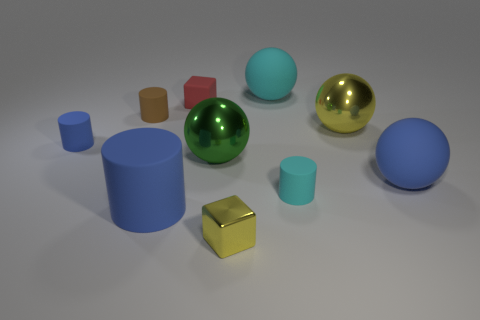Subtract all big blue rubber balls. How many balls are left? 3 Subtract all brown cylinders. How many cylinders are left? 3 Subtract all gray spheres. How many blue cylinders are left? 2 Subtract all cylinders. How many objects are left? 6 Subtract all yellow spheres. Subtract all big blue rubber balls. How many objects are left? 8 Add 5 tiny red objects. How many tiny red objects are left? 6 Add 4 green spheres. How many green spheres exist? 5 Subtract 1 cyan spheres. How many objects are left? 9 Subtract 3 cylinders. How many cylinders are left? 1 Subtract all gray cubes. Subtract all blue spheres. How many cubes are left? 2 